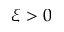Convert formula to latex. <formula><loc_0><loc_0><loc_500><loc_500>\xi > 0</formula> 